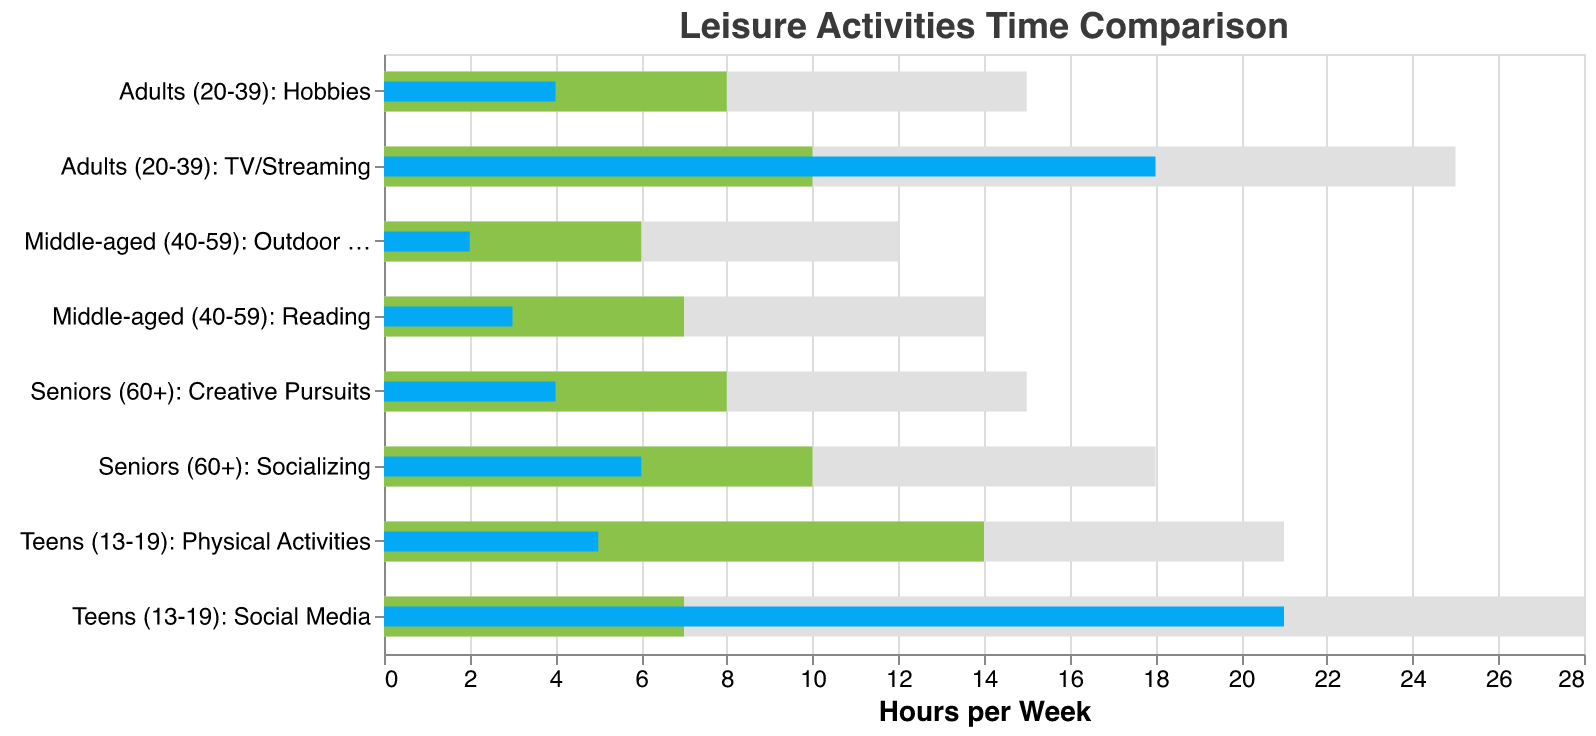What's the title of the figure? The title is prominently displayed at the top of the figure and it reads "Leisure Activities Time Comparison"
Answer: Leisure Activities Time Comparison What is the recommended time for physical activities for teens (13-19)? Look at the bar corresponding to "Teens (13-19): Physical Activities." The green bar indicates the recommended time, which is 14 hours per week based on the x-axis measurement.
Answer: 14 hours per week How much more time do teens (13-19) spend on social media than recommended? Find the actual time spent on social media by teens (13-19) compared to the recommended time. The actual time is 21 hours, and the recommended time is 7 hours. Subtract the recommended time from the actual time (21 - 7) to find the difference.
Answer: 14 hours Which age group has the largest discrepancy between actual and recommended time for a leisure activity? To find the largest discrepancy, compare the difference between actual and recommended times for each leisure activity across all age groups. For each category, subtract the recommended time from the actual time: 
Teens (13-19): Social Media = 14 hours
Teens (13-19): Physical Activities = -9 hours
Adults (20-39): TV/Streaming = 8 hours
Adults (20-39): Hobbies = -4 hours
Middle-aged (40-59): Reading = -4 hours
Middle-aged (40-59): Outdoor Activities = -4 hours
Seniors (60+): Socializing = -4 hours
Seniors (60+): Creative Pursuits = -4 hours
The largest positive discrepancy is 14 hours for Teens (13-19) in Social Media.
Answer: Teens (13-19): Social Media Which leisure activity do middle-aged individuals (40-59) spend the least amount of time on? Look at the two categories for middle-aged individuals (40-59): "Reading" and "Outdoor Activities." Compare the shorter blue bars representing actual time. "Outdoor Activities" shows 2 hours, which is less than the 3 hours for "Reading."
Answer: Outdoor Activities Does any age group meet or exceed the recommended time for their leisure activities? For each Category, compare the blue bar (actual time) to the green bar (recommended time). If the blue bar meets or exceeds the green bar, then the actual time is equal to or greater than the recommended time.
Teens (13-19): Social Media = exceeds
Teens (13-19): Physical Activities = does not
Adults (20-39): TV/Streaming = exceeds
Adults (20-39): Hobbies = does not
Middle-aged (40-59): Reading = does not
Middle-aged (40-59): Outdoor Activities = does not
Seniors (60+): Socializing = does not
Seniors (60+): Creative Pursuits = does not
Thus, only "Teens (13-19): Social Media" and "Adults (20-39): TV/Streaming" meet or exceed the recommended time.
Answer: Teens (13-19): Social Media and Adults (20-39): TV/Streaming What is the combined actual time spent on leisure activities by seniors (60+) each week? Add the actual time spent on "Socializing" and "Creative Pursuits" for seniors (60+). "Socializing" = 6 hours and "Creative Pursuits" = 4 hours. Therefore, 6 + 4 = 10 hours per week.
Answer: 10 hours per week 